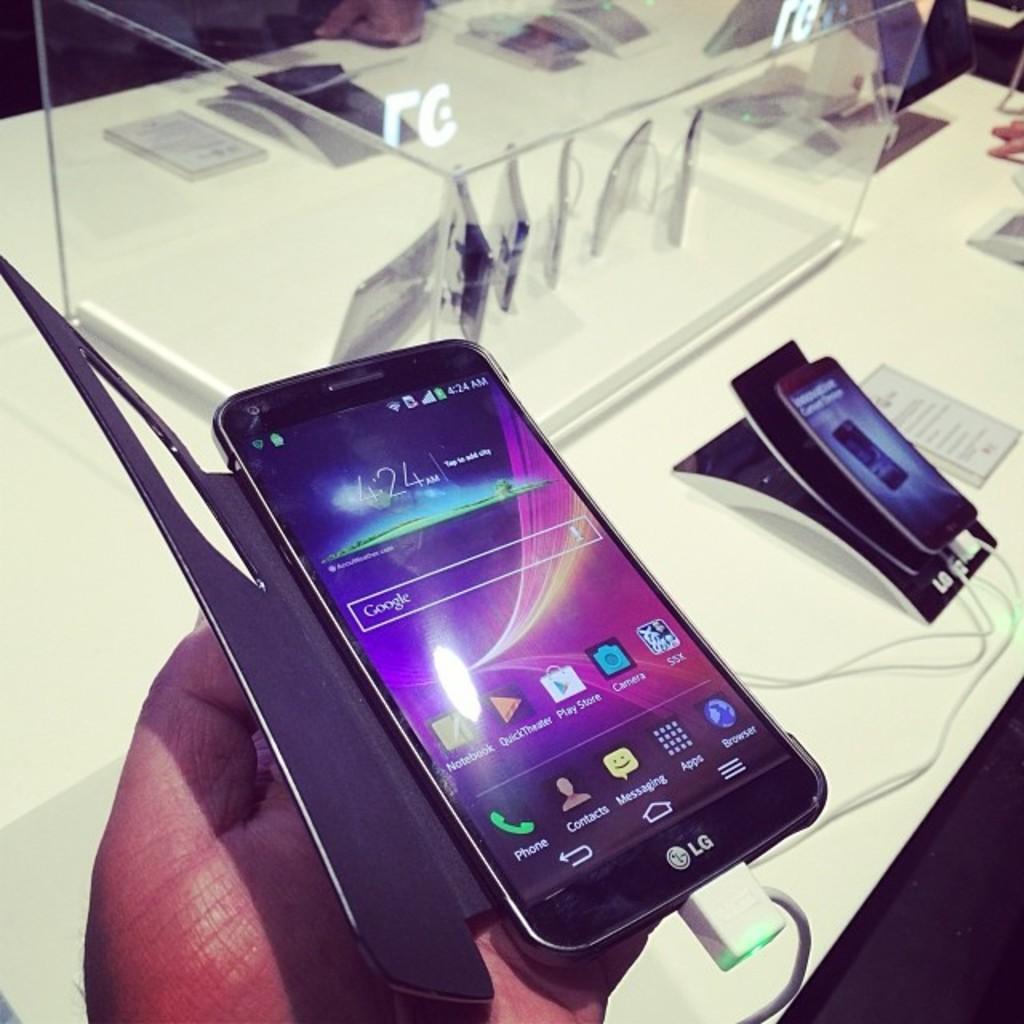What kind of phone is this?
Provide a succinct answer. Lg. What search engine can you use on the phone?
Your answer should be very brief. Google. 